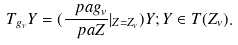<formula> <loc_0><loc_0><loc_500><loc_500>T _ { g _ { v } } Y = ( \frac { \ p a g _ { v } } { \ p a Z } | _ { Z = Z _ { v } } ) Y ; Y \in T ( Z _ { v } ) .</formula> 